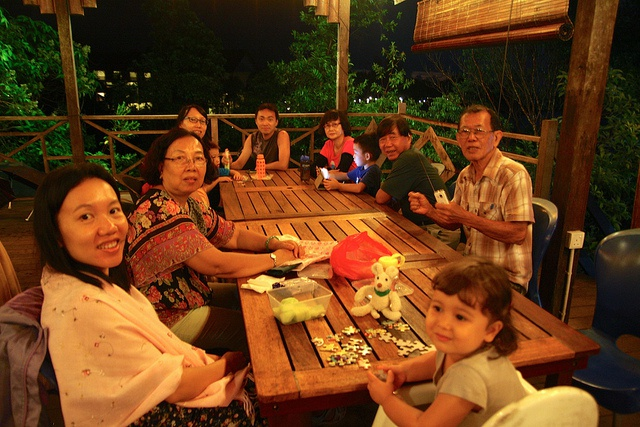Describe the objects in this image and their specific colors. I can see people in black, orange, and red tones, dining table in black, red, brown, orange, and maroon tones, people in black, brown, red, and maroon tones, people in black, red, brown, maroon, and orange tones, and people in black, brown, maroon, and red tones in this image. 